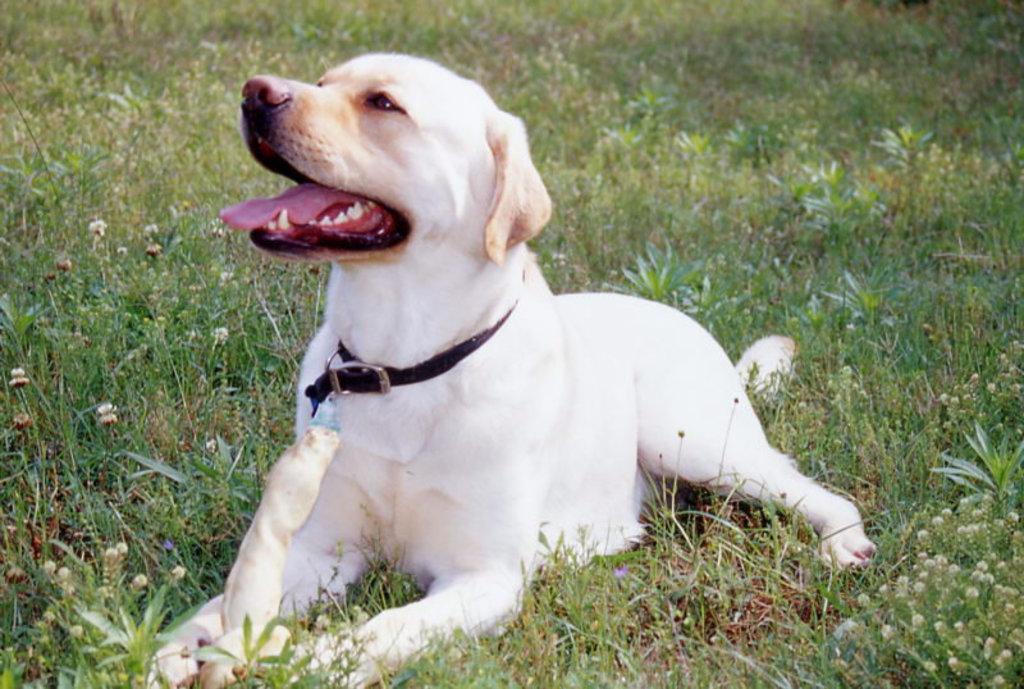Please provide a concise description of this image. This picture is clicked outside. In the center we can see a dog sitting on the ground and we can see the green grass, plants and flowers. 